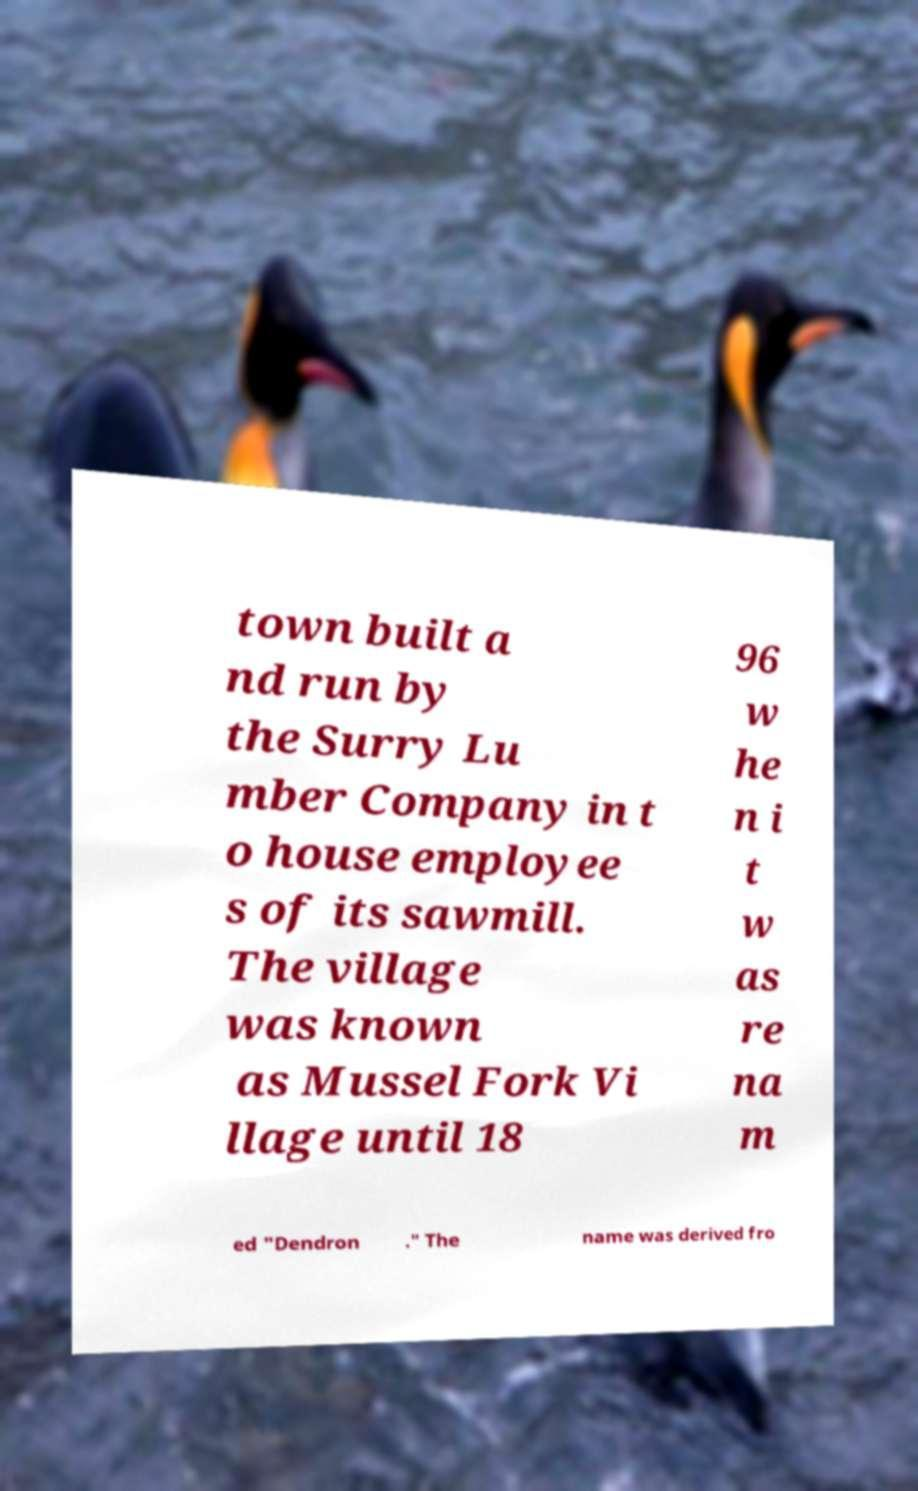There's text embedded in this image that I need extracted. Can you transcribe it verbatim? town built a nd run by the Surry Lu mber Company in t o house employee s of its sawmill. The village was known as Mussel Fork Vi llage until 18 96 w he n i t w as re na m ed "Dendron ." The name was derived fro 